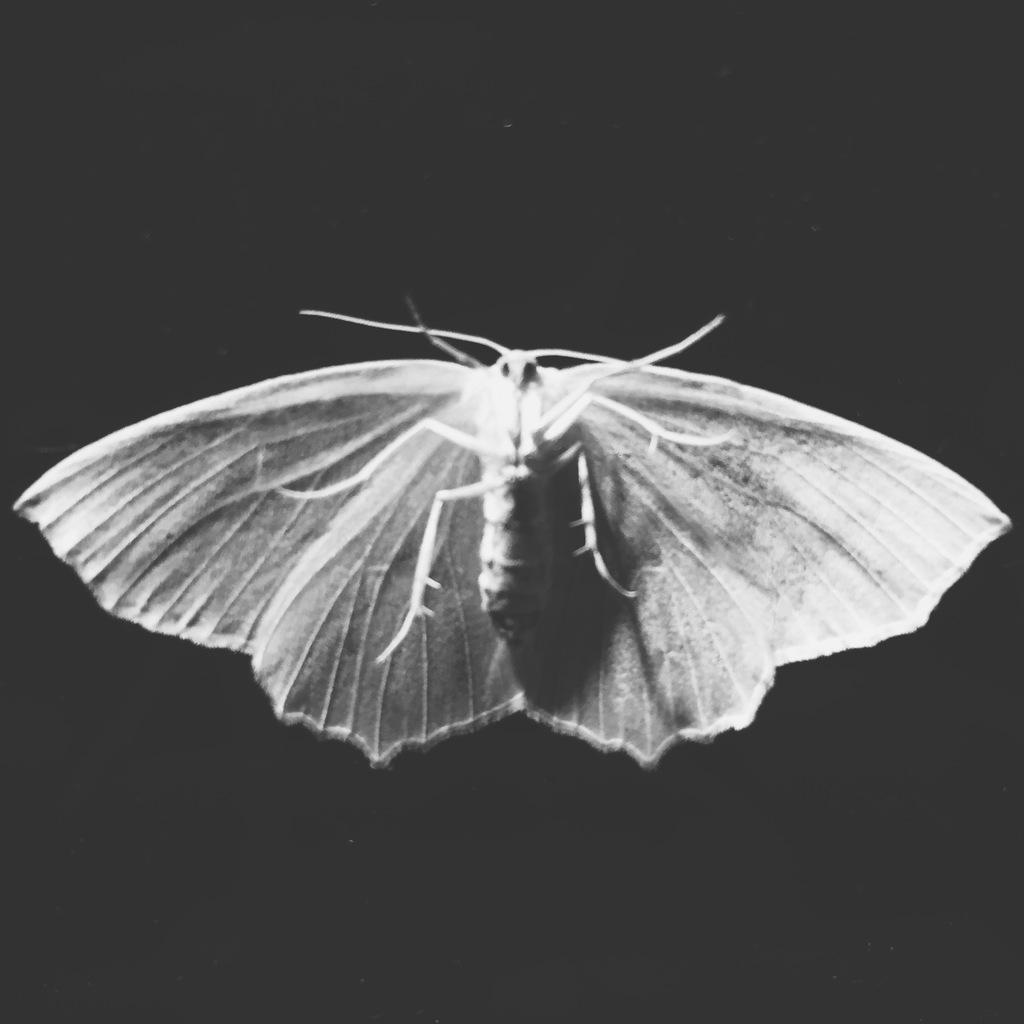What type of creature is present in the image? There is an insect in the picture. Can you describe the color of the insect? The insect is white and grey in color. What is the color of the background in the image? The background of the image is dark. What type of baseball equipment can be seen in the image? There is no baseball equipment present in the image; it features an insect with a dark background. What color is the crayon used to draw the insect in the image? There is no crayon or drawing present in the image; it is a photograph of a real insect. 